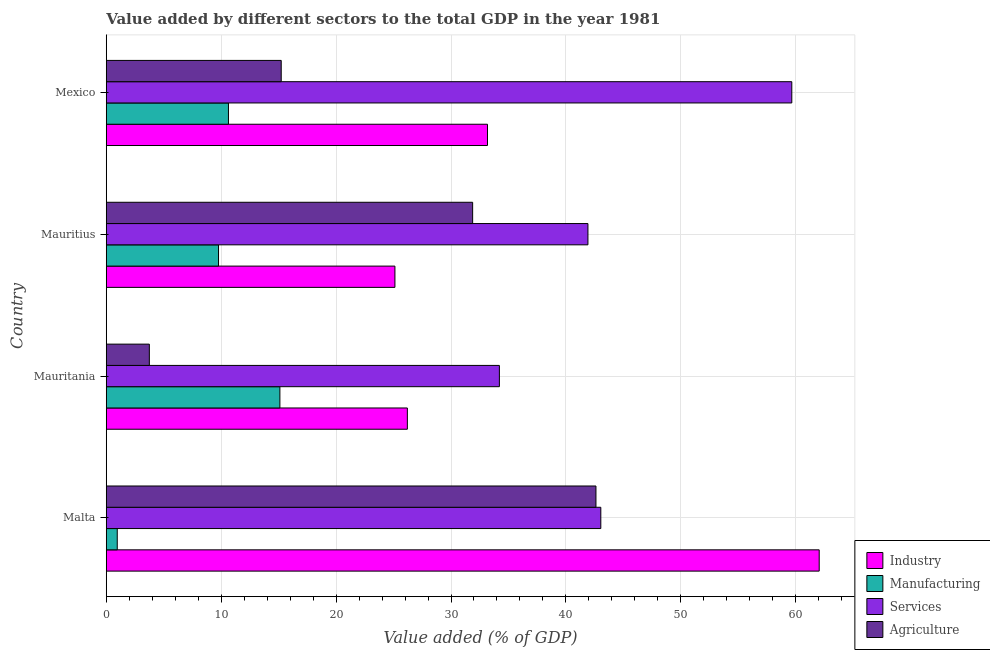How many groups of bars are there?
Offer a very short reply. 4. Are the number of bars on each tick of the Y-axis equal?
Your answer should be very brief. Yes. How many bars are there on the 2nd tick from the top?
Provide a short and direct response. 4. What is the label of the 4th group of bars from the top?
Your answer should be compact. Malta. In how many cases, is the number of bars for a given country not equal to the number of legend labels?
Your response must be concise. 0. What is the value added by services sector in Mexico?
Your response must be concise. 59.65. Across all countries, what is the maximum value added by industrial sector?
Your response must be concise. 62.04. Across all countries, what is the minimum value added by services sector?
Your answer should be compact. 34.21. In which country was the value added by agricultural sector maximum?
Offer a very short reply. Malta. In which country was the value added by manufacturing sector minimum?
Your answer should be compact. Malta. What is the total value added by industrial sector in the graph?
Make the answer very short. 146.54. What is the difference between the value added by industrial sector in Malta and that in Mauritania?
Offer a very short reply. 35.84. What is the difference between the value added by manufacturing sector in Malta and the value added by industrial sector in Mauritius?
Make the answer very short. -24.16. What is the average value added by services sector per country?
Your answer should be very brief. 44.7. What is the difference between the value added by services sector and value added by manufacturing sector in Mexico?
Your answer should be very brief. 49.02. In how many countries, is the value added by services sector greater than 8 %?
Provide a succinct answer. 4. What is the ratio of the value added by manufacturing sector in Malta to that in Mauritius?
Provide a short and direct response. 0.1. Is the value added by agricultural sector in Mauritania less than that in Mauritius?
Make the answer very short. Yes. Is the difference between the value added by agricultural sector in Mauritania and Mexico greater than the difference between the value added by services sector in Mauritania and Mexico?
Provide a succinct answer. Yes. What is the difference between the highest and the second highest value added by industrial sector?
Your response must be concise. 28.87. What is the difference between the highest and the lowest value added by services sector?
Provide a succinct answer. 25.44. What does the 3rd bar from the top in Mauritania represents?
Give a very brief answer. Manufacturing. What does the 3rd bar from the bottom in Mauritania represents?
Provide a succinct answer. Services. Is it the case that in every country, the sum of the value added by industrial sector and value added by manufacturing sector is greater than the value added by services sector?
Your answer should be very brief. No. Are all the bars in the graph horizontal?
Provide a short and direct response. Yes. Does the graph contain any zero values?
Your answer should be compact. No. Does the graph contain grids?
Keep it short and to the point. Yes. How are the legend labels stacked?
Provide a short and direct response. Vertical. What is the title of the graph?
Make the answer very short. Value added by different sectors to the total GDP in the year 1981. What is the label or title of the X-axis?
Make the answer very short. Value added (% of GDP). What is the Value added (% of GDP) of Industry in Malta?
Keep it short and to the point. 62.04. What is the Value added (% of GDP) of Manufacturing in Malta?
Your answer should be very brief. 0.96. What is the Value added (% of GDP) in Services in Malta?
Offer a very short reply. 43.04. What is the Value added (% of GDP) in Agriculture in Malta?
Offer a very short reply. 42.61. What is the Value added (% of GDP) in Industry in Mauritania?
Provide a short and direct response. 26.2. What is the Value added (% of GDP) of Manufacturing in Mauritania?
Ensure brevity in your answer.  15.11. What is the Value added (% of GDP) of Services in Mauritania?
Your answer should be compact. 34.21. What is the Value added (% of GDP) of Agriculture in Mauritania?
Provide a succinct answer. 3.75. What is the Value added (% of GDP) of Industry in Mauritius?
Your response must be concise. 25.12. What is the Value added (% of GDP) of Manufacturing in Mauritius?
Offer a very short reply. 9.77. What is the Value added (% of GDP) of Services in Mauritius?
Provide a short and direct response. 41.92. What is the Value added (% of GDP) in Agriculture in Mauritius?
Keep it short and to the point. 31.88. What is the Value added (% of GDP) of Industry in Mexico?
Provide a short and direct response. 33.17. What is the Value added (% of GDP) of Manufacturing in Mexico?
Offer a very short reply. 10.63. What is the Value added (% of GDP) of Services in Mexico?
Provide a short and direct response. 59.65. What is the Value added (% of GDP) of Agriculture in Mexico?
Your answer should be compact. 15.23. Across all countries, what is the maximum Value added (% of GDP) of Industry?
Give a very brief answer. 62.04. Across all countries, what is the maximum Value added (% of GDP) of Manufacturing?
Offer a terse response. 15.11. Across all countries, what is the maximum Value added (% of GDP) of Services?
Your response must be concise. 59.65. Across all countries, what is the maximum Value added (% of GDP) of Agriculture?
Offer a terse response. 42.61. Across all countries, what is the minimum Value added (% of GDP) of Industry?
Give a very brief answer. 25.12. Across all countries, what is the minimum Value added (% of GDP) of Manufacturing?
Your answer should be compact. 0.96. Across all countries, what is the minimum Value added (% of GDP) of Services?
Your response must be concise. 34.21. Across all countries, what is the minimum Value added (% of GDP) in Agriculture?
Make the answer very short. 3.75. What is the total Value added (% of GDP) in Industry in the graph?
Your answer should be very brief. 146.54. What is the total Value added (% of GDP) in Manufacturing in the graph?
Offer a terse response. 36.47. What is the total Value added (% of GDP) in Services in the graph?
Ensure brevity in your answer.  178.82. What is the total Value added (% of GDP) of Agriculture in the graph?
Provide a succinct answer. 93.47. What is the difference between the Value added (% of GDP) in Industry in Malta and that in Mauritania?
Your answer should be very brief. 35.84. What is the difference between the Value added (% of GDP) in Manufacturing in Malta and that in Mauritania?
Offer a terse response. -14.15. What is the difference between the Value added (% of GDP) in Services in Malta and that in Mauritania?
Offer a terse response. 8.83. What is the difference between the Value added (% of GDP) in Agriculture in Malta and that in Mauritania?
Provide a succinct answer. 38.86. What is the difference between the Value added (% of GDP) of Industry in Malta and that in Mauritius?
Keep it short and to the point. 36.92. What is the difference between the Value added (% of GDP) of Manufacturing in Malta and that in Mauritius?
Make the answer very short. -8.81. What is the difference between the Value added (% of GDP) in Services in Malta and that in Mauritius?
Your answer should be very brief. 1.12. What is the difference between the Value added (% of GDP) of Agriculture in Malta and that in Mauritius?
Your response must be concise. 10.73. What is the difference between the Value added (% of GDP) of Industry in Malta and that in Mexico?
Make the answer very short. 28.87. What is the difference between the Value added (% of GDP) in Manufacturing in Malta and that in Mexico?
Give a very brief answer. -9.68. What is the difference between the Value added (% of GDP) of Services in Malta and that in Mexico?
Your answer should be compact. -16.62. What is the difference between the Value added (% of GDP) of Agriculture in Malta and that in Mexico?
Your answer should be very brief. 27.39. What is the difference between the Value added (% of GDP) in Industry in Mauritania and that in Mauritius?
Ensure brevity in your answer.  1.08. What is the difference between the Value added (% of GDP) in Manufacturing in Mauritania and that in Mauritius?
Your response must be concise. 5.34. What is the difference between the Value added (% of GDP) of Services in Mauritania and that in Mauritius?
Offer a terse response. -7.71. What is the difference between the Value added (% of GDP) in Agriculture in Mauritania and that in Mauritius?
Your answer should be compact. -28.13. What is the difference between the Value added (% of GDP) of Industry in Mauritania and that in Mexico?
Keep it short and to the point. -6.97. What is the difference between the Value added (% of GDP) of Manufacturing in Mauritania and that in Mexico?
Your response must be concise. 4.47. What is the difference between the Value added (% of GDP) of Services in Mauritania and that in Mexico?
Your response must be concise. -25.44. What is the difference between the Value added (% of GDP) in Agriculture in Mauritania and that in Mexico?
Offer a terse response. -11.48. What is the difference between the Value added (% of GDP) of Industry in Mauritius and that in Mexico?
Your answer should be very brief. -8.05. What is the difference between the Value added (% of GDP) of Manufacturing in Mauritius and that in Mexico?
Your answer should be very brief. -0.86. What is the difference between the Value added (% of GDP) in Services in Mauritius and that in Mexico?
Your response must be concise. -17.74. What is the difference between the Value added (% of GDP) of Agriculture in Mauritius and that in Mexico?
Ensure brevity in your answer.  16.66. What is the difference between the Value added (% of GDP) of Industry in Malta and the Value added (% of GDP) of Manufacturing in Mauritania?
Provide a short and direct response. 46.93. What is the difference between the Value added (% of GDP) of Industry in Malta and the Value added (% of GDP) of Services in Mauritania?
Keep it short and to the point. 27.83. What is the difference between the Value added (% of GDP) of Industry in Malta and the Value added (% of GDP) of Agriculture in Mauritania?
Offer a very short reply. 58.29. What is the difference between the Value added (% of GDP) of Manufacturing in Malta and the Value added (% of GDP) of Services in Mauritania?
Provide a succinct answer. -33.25. What is the difference between the Value added (% of GDP) in Manufacturing in Malta and the Value added (% of GDP) in Agriculture in Mauritania?
Offer a terse response. -2.79. What is the difference between the Value added (% of GDP) of Services in Malta and the Value added (% of GDP) of Agriculture in Mauritania?
Offer a very short reply. 39.29. What is the difference between the Value added (% of GDP) of Industry in Malta and the Value added (% of GDP) of Manufacturing in Mauritius?
Ensure brevity in your answer.  52.27. What is the difference between the Value added (% of GDP) of Industry in Malta and the Value added (% of GDP) of Services in Mauritius?
Make the answer very short. 20.12. What is the difference between the Value added (% of GDP) in Industry in Malta and the Value added (% of GDP) in Agriculture in Mauritius?
Give a very brief answer. 30.16. What is the difference between the Value added (% of GDP) in Manufacturing in Malta and the Value added (% of GDP) in Services in Mauritius?
Make the answer very short. -40.96. What is the difference between the Value added (% of GDP) of Manufacturing in Malta and the Value added (% of GDP) of Agriculture in Mauritius?
Your answer should be compact. -30.93. What is the difference between the Value added (% of GDP) in Services in Malta and the Value added (% of GDP) in Agriculture in Mauritius?
Provide a short and direct response. 11.15. What is the difference between the Value added (% of GDP) in Industry in Malta and the Value added (% of GDP) in Manufacturing in Mexico?
Provide a succinct answer. 51.41. What is the difference between the Value added (% of GDP) of Industry in Malta and the Value added (% of GDP) of Services in Mexico?
Offer a terse response. 2.39. What is the difference between the Value added (% of GDP) of Industry in Malta and the Value added (% of GDP) of Agriculture in Mexico?
Keep it short and to the point. 46.81. What is the difference between the Value added (% of GDP) in Manufacturing in Malta and the Value added (% of GDP) in Services in Mexico?
Give a very brief answer. -58.7. What is the difference between the Value added (% of GDP) of Manufacturing in Malta and the Value added (% of GDP) of Agriculture in Mexico?
Offer a terse response. -14.27. What is the difference between the Value added (% of GDP) of Services in Malta and the Value added (% of GDP) of Agriculture in Mexico?
Your answer should be very brief. 27.81. What is the difference between the Value added (% of GDP) in Industry in Mauritania and the Value added (% of GDP) in Manufacturing in Mauritius?
Make the answer very short. 16.43. What is the difference between the Value added (% of GDP) in Industry in Mauritania and the Value added (% of GDP) in Services in Mauritius?
Ensure brevity in your answer.  -15.71. What is the difference between the Value added (% of GDP) in Industry in Mauritania and the Value added (% of GDP) in Agriculture in Mauritius?
Provide a succinct answer. -5.68. What is the difference between the Value added (% of GDP) in Manufacturing in Mauritania and the Value added (% of GDP) in Services in Mauritius?
Your response must be concise. -26.81. What is the difference between the Value added (% of GDP) of Manufacturing in Mauritania and the Value added (% of GDP) of Agriculture in Mauritius?
Ensure brevity in your answer.  -16.77. What is the difference between the Value added (% of GDP) in Services in Mauritania and the Value added (% of GDP) in Agriculture in Mauritius?
Your answer should be compact. 2.33. What is the difference between the Value added (% of GDP) of Industry in Mauritania and the Value added (% of GDP) of Manufacturing in Mexico?
Make the answer very short. 15.57. What is the difference between the Value added (% of GDP) in Industry in Mauritania and the Value added (% of GDP) in Services in Mexico?
Provide a succinct answer. -33.45. What is the difference between the Value added (% of GDP) of Industry in Mauritania and the Value added (% of GDP) of Agriculture in Mexico?
Provide a short and direct response. 10.98. What is the difference between the Value added (% of GDP) of Manufacturing in Mauritania and the Value added (% of GDP) of Services in Mexico?
Provide a succinct answer. -44.55. What is the difference between the Value added (% of GDP) in Manufacturing in Mauritania and the Value added (% of GDP) in Agriculture in Mexico?
Give a very brief answer. -0.12. What is the difference between the Value added (% of GDP) of Services in Mauritania and the Value added (% of GDP) of Agriculture in Mexico?
Your answer should be compact. 18.98. What is the difference between the Value added (% of GDP) in Industry in Mauritius and the Value added (% of GDP) in Manufacturing in Mexico?
Provide a short and direct response. 14.49. What is the difference between the Value added (% of GDP) in Industry in Mauritius and the Value added (% of GDP) in Services in Mexico?
Your answer should be compact. -34.53. What is the difference between the Value added (% of GDP) in Industry in Mauritius and the Value added (% of GDP) in Agriculture in Mexico?
Provide a succinct answer. 9.89. What is the difference between the Value added (% of GDP) in Manufacturing in Mauritius and the Value added (% of GDP) in Services in Mexico?
Offer a terse response. -49.88. What is the difference between the Value added (% of GDP) in Manufacturing in Mauritius and the Value added (% of GDP) in Agriculture in Mexico?
Your response must be concise. -5.46. What is the difference between the Value added (% of GDP) of Services in Mauritius and the Value added (% of GDP) of Agriculture in Mexico?
Provide a short and direct response. 26.69. What is the average Value added (% of GDP) of Industry per country?
Your answer should be very brief. 36.63. What is the average Value added (% of GDP) of Manufacturing per country?
Provide a succinct answer. 9.12. What is the average Value added (% of GDP) of Services per country?
Your answer should be compact. 44.7. What is the average Value added (% of GDP) in Agriculture per country?
Offer a very short reply. 23.37. What is the difference between the Value added (% of GDP) in Industry and Value added (% of GDP) in Manufacturing in Malta?
Offer a very short reply. 61.08. What is the difference between the Value added (% of GDP) of Industry and Value added (% of GDP) of Services in Malta?
Provide a succinct answer. 19. What is the difference between the Value added (% of GDP) of Industry and Value added (% of GDP) of Agriculture in Malta?
Provide a short and direct response. 19.43. What is the difference between the Value added (% of GDP) in Manufacturing and Value added (% of GDP) in Services in Malta?
Keep it short and to the point. -42.08. What is the difference between the Value added (% of GDP) of Manufacturing and Value added (% of GDP) of Agriculture in Malta?
Make the answer very short. -41.66. What is the difference between the Value added (% of GDP) of Services and Value added (% of GDP) of Agriculture in Malta?
Your answer should be compact. 0.42. What is the difference between the Value added (% of GDP) in Industry and Value added (% of GDP) in Manufacturing in Mauritania?
Offer a very short reply. 11.09. What is the difference between the Value added (% of GDP) of Industry and Value added (% of GDP) of Services in Mauritania?
Ensure brevity in your answer.  -8.01. What is the difference between the Value added (% of GDP) in Industry and Value added (% of GDP) in Agriculture in Mauritania?
Make the answer very short. 22.45. What is the difference between the Value added (% of GDP) of Manufacturing and Value added (% of GDP) of Services in Mauritania?
Make the answer very short. -19.1. What is the difference between the Value added (% of GDP) of Manufacturing and Value added (% of GDP) of Agriculture in Mauritania?
Give a very brief answer. 11.36. What is the difference between the Value added (% of GDP) of Services and Value added (% of GDP) of Agriculture in Mauritania?
Offer a very short reply. 30.46. What is the difference between the Value added (% of GDP) in Industry and Value added (% of GDP) in Manufacturing in Mauritius?
Your response must be concise. 15.35. What is the difference between the Value added (% of GDP) in Industry and Value added (% of GDP) in Services in Mauritius?
Offer a terse response. -16.8. What is the difference between the Value added (% of GDP) of Industry and Value added (% of GDP) of Agriculture in Mauritius?
Offer a very short reply. -6.76. What is the difference between the Value added (% of GDP) of Manufacturing and Value added (% of GDP) of Services in Mauritius?
Make the answer very short. -32.15. What is the difference between the Value added (% of GDP) of Manufacturing and Value added (% of GDP) of Agriculture in Mauritius?
Offer a very short reply. -22.11. What is the difference between the Value added (% of GDP) of Services and Value added (% of GDP) of Agriculture in Mauritius?
Offer a very short reply. 10.03. What is the difference between the Value added (% of GDP) in Industry and Value added (% of GDP) in Manufacturing in Mexico?
Offer a terse response. 22.54. What is the difference between the Value added (% of GDP) of Industry and Value added (% of GDP) of Services in Mexico?
Give a very brief answer. -26.48. What is the difference between the Value added (% of GDP) of Industry and Value added (% of GDP) of Agriculture in Mexico?
Offer a terse response. 17.95. What is the difference between the Value added (% of GDP) of Manufacturing and Value added (% of GDP) of Services in Mexico?
Offer a terse response. -49.02. What is the difference between the Value added (% of GDP) of Manufacturing and Value added (% of GDP) of Agriculture in Mexico?
Provide a succinct answer. -4.59. What is the difference between the Value added (% of GDP) in Services and Value added (% of GDP) in Agriculture in Mexico?
Provide a short and direct response. 44.43. What is the ratio of the Value added (% of GDP) of Industry in Malta to that in Mauritania?
Offer a very short reply. 2.37. What is the ratio of the Value added (% of GDP) in Manufacturing in Malta to that in Mauritania?
Give a very brief answer. 0.06. What is the ratio of the Value added (% of GDP) in Services in Malta to that in Mauritania?
Offer a very short reply. 1.26. What is the ratio of the Value added (% of GDP) in Agriculture in Malta to that in Mauritania?
Offer a very short reply. 11.36. What is the ratio of the Value added (% of GDP) in Industry in Malta to that in Mauritius?
Ensure brevity in your answer.  2.47. What is the ratio of the Value added (% of GDP) of Manufacturing in Malta to that in Mauritius?
Provide a short and direct response. 0.1. What is the ratio of the Value added (% of GDP) in Services in Malta to that in Mauritius?
Your answer should be very brief. 1.03. What is the ratio of the Value added (% of GDP) in Agriculture in Malta to that in Mauritius?
Keep it short and to the point. 1.34. What is the ratio of the Value added (% of GDP) of Industry in Malta to that in Mexico?
Give a very brief answer. 1.87. What is the ratio of the Value added (% of GDP) of Manufacturing in Malta to that in Mexico?
Keep it short and to the point. 0.09. What is the ratio of the Value added (% of GDP) of Services in Malta to that in Mexico?
Your answer should be compact. 0.72. What is the ratio of the Value added (% of GDP) in Agriculture in Malta to that in Mexico?
Your response must be concise. 2.8. What is the ratio of the Value added (% of GDP) of Industry in Mauritania to that in Mauritius?
Provide a short and direct response. 1.04. What is the ratio of the Value added (% of GDP) of Manufacturing in Mauritania to that in Mauritius?
Offer a terse response. 1.55. What is the ratio of the Value added (% of GDP) of Services in Mauritania to that in Mauritius?
Your answer should be very brief. 0.82. What is the ratio of the Value added (% of GDP) of Agriculture in Mauritania to that in Mauritius?
Provide a succinct answer. 0.12. What is the ratio of the Value added (% of GDP) in Industry in Mauritania to that in Mexico?
Provide a succinct answer. 0.79. What is the ratio of the Value added (% of GDP) in Manufacturing in Mauritania to that in Mexico?
Your answer should be compact. 1.42. What is the ratio of the Value added (% of GDP) of Services in Mauritania to that in Mexico?
Your answer should be compact. 0.57. What is the ratio of the Value added (% of GDP) in Agriculture in Mauritania to that in Mexico?
Ensure brevity in your answer.  0.25. What is the ratio of the Value added (% of GDP) of Industry in Mauritius to that in Mexico?
Provide a succinct answer. 0.76. What is the ratio of the Value added (% of GDP) of Manufacturing in Mauritius to that in Mexico?
Make the answer very short. 0.92. What is the ratio of the Value added (% of GDP) in Services in Mauritius to that in Mexico?
Make the answer very short. 0.7. What is the ratio of the Value added (% of GDP) in Agriculture in Mauritius to that in Mexico?
Offer a terse response. 2.09. What is the difference between the highest and the second highest Value added (% of GDP) of Industry?
Make the answer very short. 28.87. What is the difference between the highest and the second highest Value added (% of GDP) of Manufacturing?
Provide a succinct answer. 4.47. What is the difference between the highest and the second highest Value added (% of GDP) in Services?
Give a very brief answer. 16.62. What is the difference between the highest and the second highest Value added (% of GDP) of Agriculture?
Provide a succinct answer. 10.73. What is the difference between the highest and the lowest Value added (% of GDP) of Industry?
Your answer should be very brief. 36.92. What is the difference between the highest and the lowest Value added (% of GDP) of Manufacturing?
Keep it short and to the point. 14.15. What is the difference between the highest and the lowest Value added (% of GDP) of Services?
Make the answer very short. 25.44. What is the difference between the highest and the lowest Value added (% of GDP) of Agriculture?
Give a very brief answer. 38.86. 